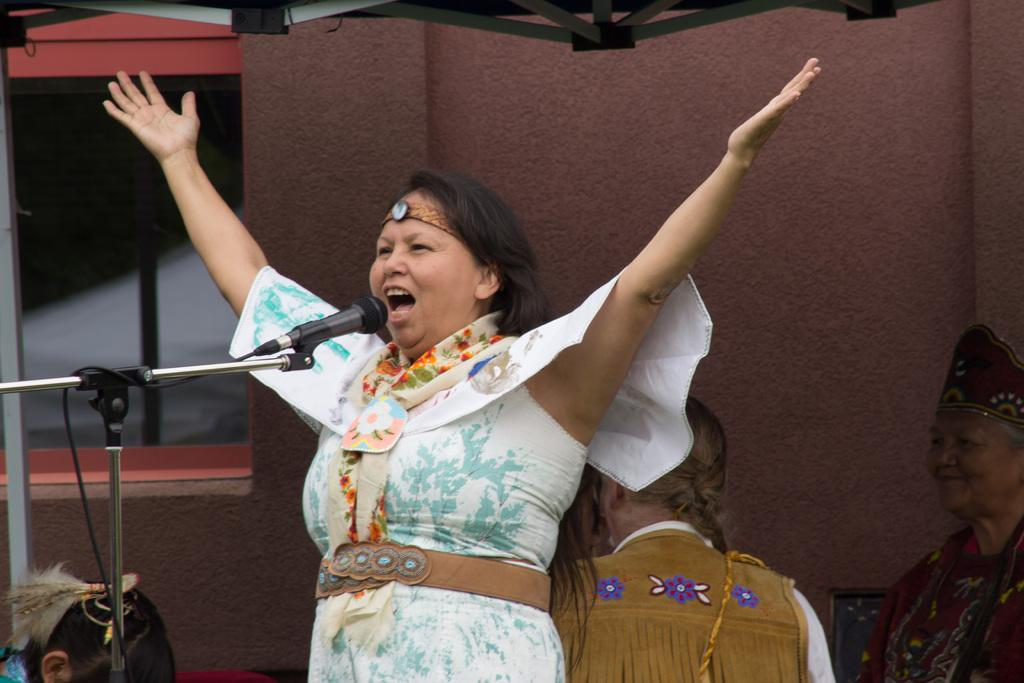Who is the main subject in the image? There is a woman in the image. What is the woman wearing? The woman is wearing a white dress. Where is the woman located in the image? The woman is standing on a stage. What is the woman doing on the stage? The woman is using a microphone. What can be seen in the background of the image? There is a wall in the background of the image, and there is an iron frame on the top of the wall. How much wealth is displayed in the image? There is no indication of wealth in the image; it features a woman on a stage using a microphone. Can you describe the woman stretching her arms in the image? There is no instance of the woman stretching her arms in the image; she is using a microphone while standing on a stage. 